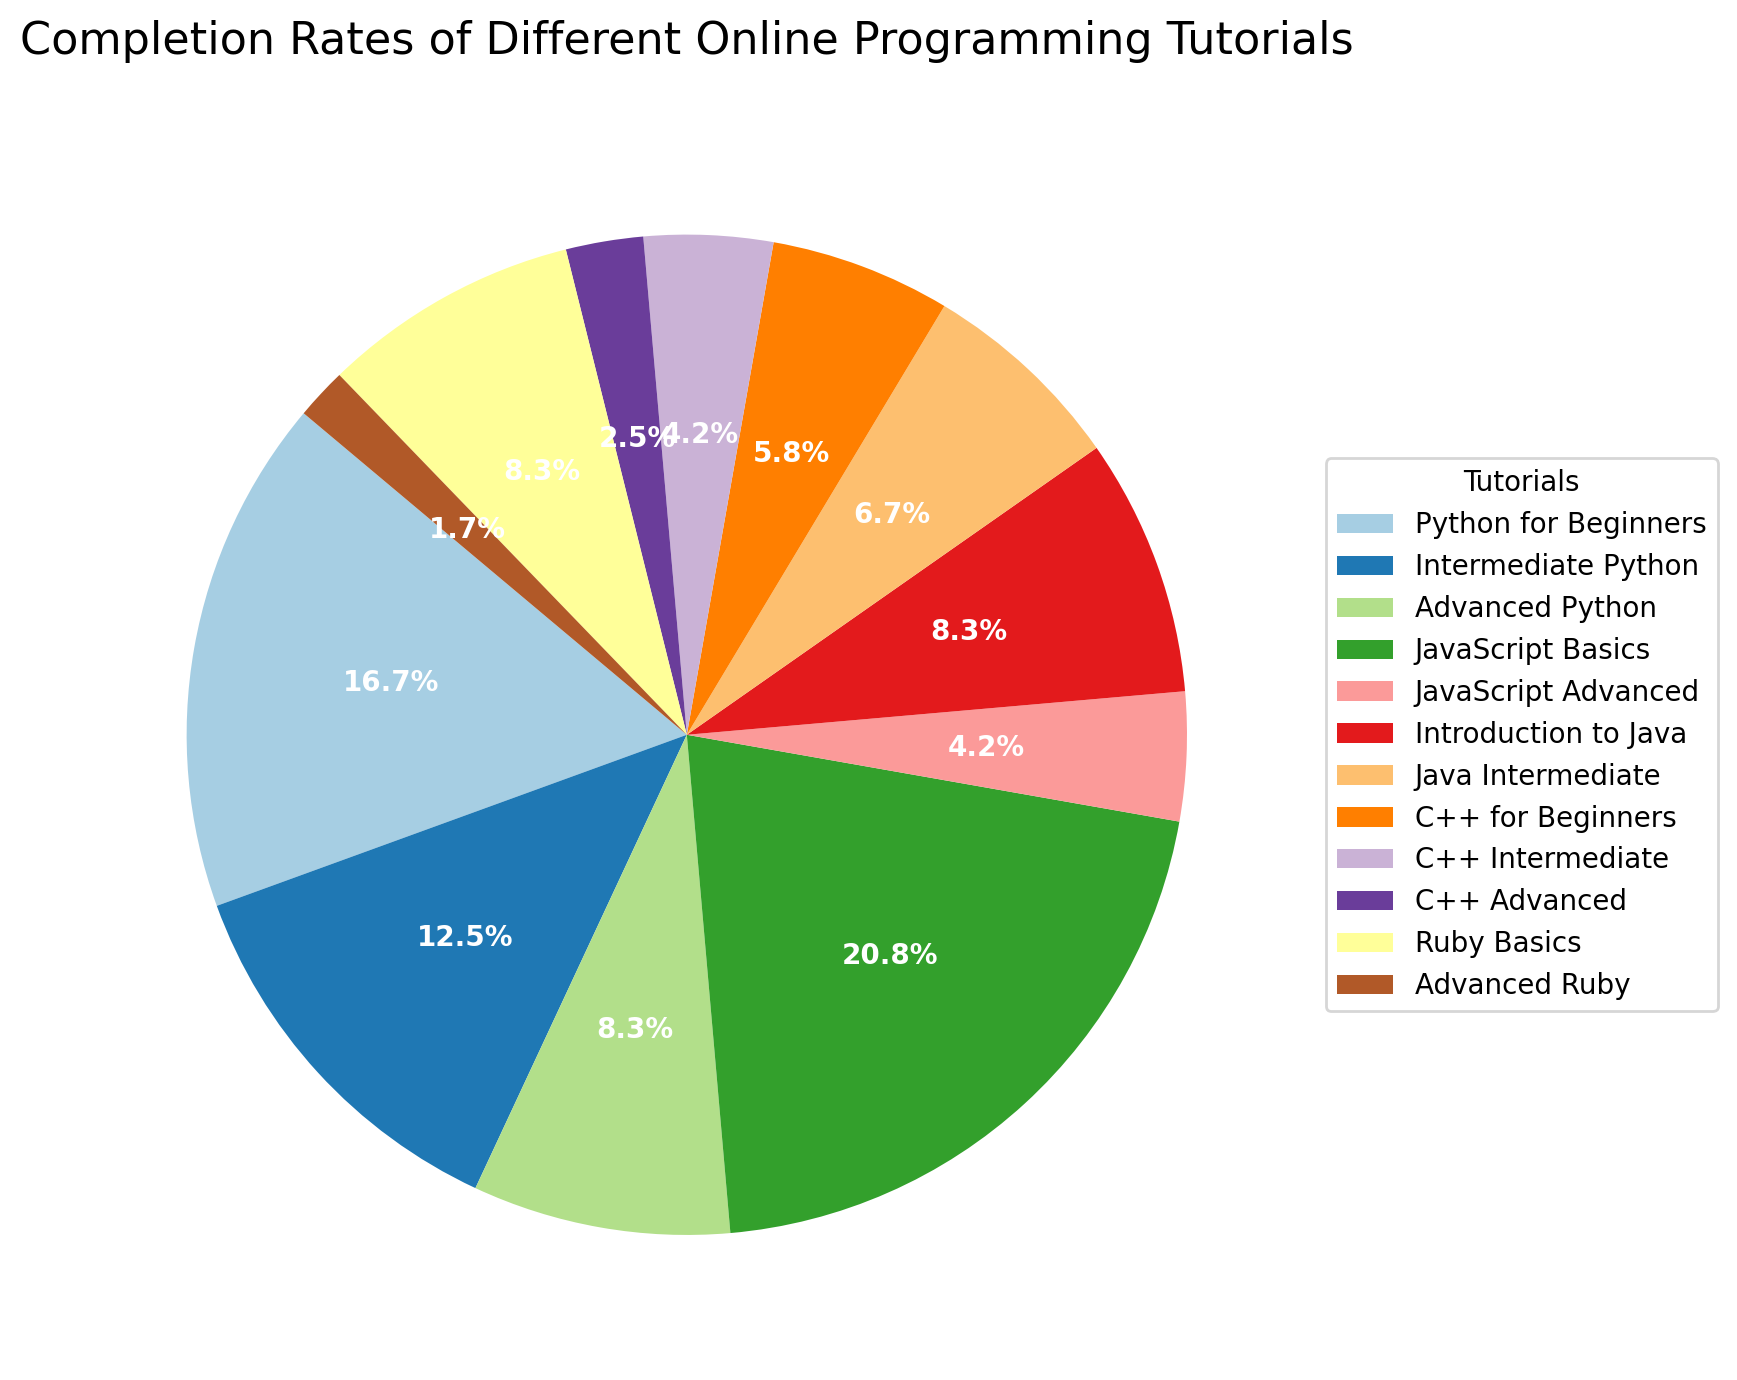Which tutorial has the highest completion rate? To determine the tutorial with the highest completion rate, observe each segment of the pie chart and look for the one with the largest slice. In this case, the "JavaScript Basics" segment is the largest, indicating it has the highest completion rate.
Answer: JavaScript Basics What percentage of tutorials combined make up the Intermediate Python and Java Intermediate completion rates? Look at the pie chart and find the segments for "Intermediate Python" and "Java Intermediate". "Intermediate Python" has a completion rate of 15%, and "Java Intermediate" has 8%. Adding these percentages together: 15% + 8% = 23%.
Answer: 23% How does the completion rate of Advanced Ruby compare to that of Advanced Python? Identify the segments for "Advanced Ruby" and "Advanced Python" in the pie chart. "Advanced Ruby" has a completion rate of 2%, while "Advanced Python" has a completion rate of 10%. Comparing the two percentages, we see that the completion rate of "Advanced Python" is higher than "Advanced Ruby".
Answer: Advanced Python is higher Which tutorials have a completion rate of less than 10%? Look for the segments of the pie chart that represent completion rates less than 10%. Referencing the data labels: "JavaScript Advanced" (5%), "C++ Intermediate" (5%), "C++ Advanced" (3%), and "Advanced Ruby" (2%) all have completion rates less than 10%.
Answer: JavaScript Advanced, C++ Intermediate, C++ Advanced, Advanced Ruby What is the combined completion rate for all Python tutorials? Identify the segments for "Python for Beginners" (20%), "Intermediate Python" (15%), and "Advanced Python" (10%). Sum these percentages: 20% + 15% + 10% = 45%.
Answer: 45% What is the difference in the completion rates between "JavaScript Basics" and "Introduction to Java"? Find the segments for "JavaScript Basics" and "Introduction to Java" in the pie chart. "JavaScript Basics" has a completion rate of 25%, while "Introduction to Java" has 10%. Calculate the difference: 25% - 10% = 15%.
Answer: 15% Which segment has the smallest completion rate and what is its value? Observe the smallest segment in the pie chart, representing the "Advanced Ruby" tutorial. The data label for this segment shows it has a completion rate of 2%, indicating it is the smallest.
Answer: Advanced Ruby, 2% How many tutorials have completion rates between 5% and 10% inclusive? Refer to the pie chart and identify segments within the 5% to 10% range. The segments that fit this criterion are "Introduction to Java" (10%), "Java Intermediate" (8%), "C++ for Beginners" (7%), "C++ Intermediate" (5%). Count these segments: 4 tutorials.
Answer: 4 What is the total percentage of completion rates for all JavaScript tutorials? The JavaScript tutorials include "JavaScript Basics" (25%) and "JavaScript Advanced" (5%). Adding these percentages together gives 25% + 5% = 30%.
Answer: 30% What color represents the "C++ Advanced" tutorial in the pie chart? Look at the pie chart and locate the segment for "C++ Advanced". Note the color used to represent this segment. This may vary based on the chart, but you can visually match colors to corresponding labels in the legend.
Answer: [The specific color used in the pie chart, e.g., Light Blue - This depends on the chart's color mapping and should be observed directly.] 